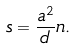Convert formula to latex. <formula><loc_0><loc_0><loc_500><loc_500>s = \frac { a ^ { 2 } } { d } n .</formula> 